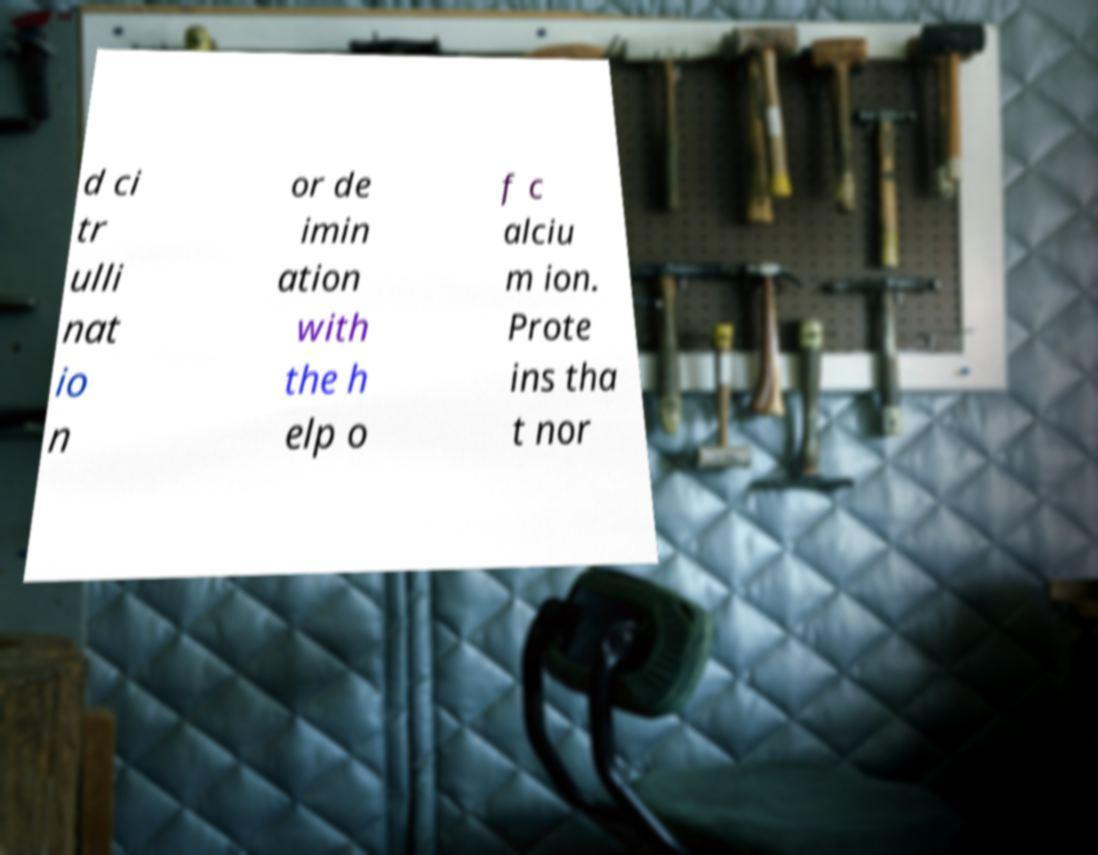What messages or text are displayed in this image? I need them in a readable, typed format. d ci tr ulli nat io n or de imin ation with the h elp o f c alciu m ion. Prote ins tha t nor 